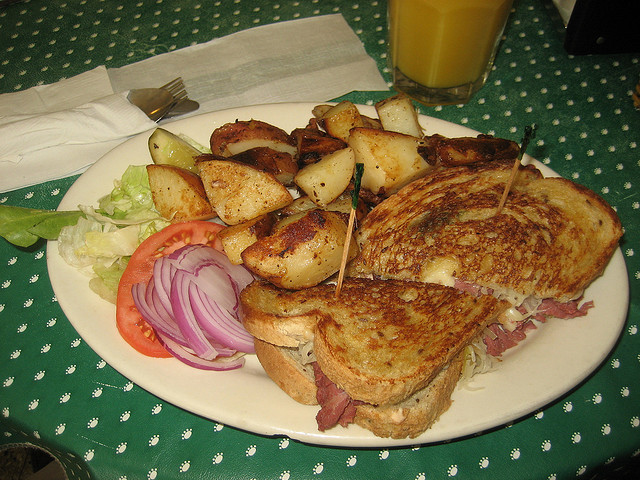<image>How many calories are in this meal? It is ambiguous the caloric content of this meal. It can be varied from a lot to a specific number. How many calories are in this meal? I am not sure how many calories are in this meal. 